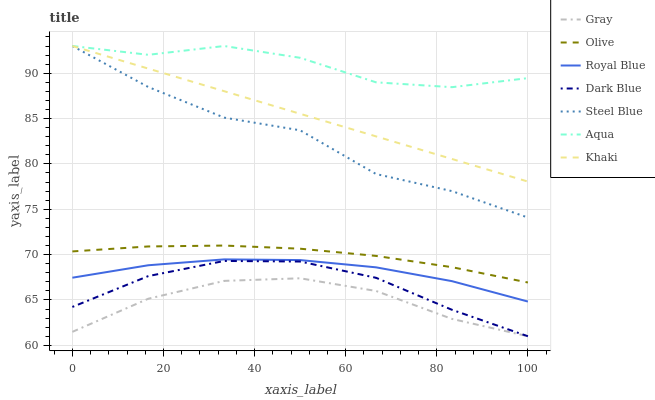Does Gray have the minimum area under the curve?
Answer yes or no. Yes. Does Aqua have the maximum area under the curve?
Answer yes or no. Yes. Does Khaki have the minimum area under the curve?
Answer yes or no. No. Does Khaki have the maximum area under the curve?
Answer yes or no. No. Is Khaki the smoothest?
Answer yes or no. Yes. Is Steel Blue the roughest?
Answer yes or no. Yes. Is Royal Blue the smoothest?
Answer yes or no. No. Is Royal Blue the roughest?
Answer yes or no. No. Does Khaki have the lowest value?
Answer yes or no. No. Does Steel Blue have the highest value?
Answer yes or no. Yes. Does Royal Blue have the highest value?
Answer yes or no. No. Is Gray less than Royal Blue?
Answer yes or no. Yes. Is Steel Blue greater than Royal Blue?
Answer yes or no. Yes. Does Khaki intersect Aqua?
Answer yes or no. Yes. Is Khaki less than Aqua?
Answer yes or no. No. Is Khaki greater than Aqua?
Answer yes or no. No. Does Gray intersect Royal Blue?
Answer yes or no. No. 